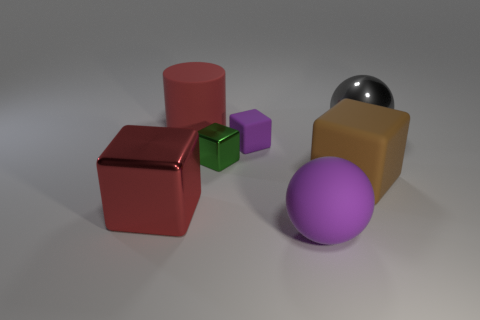Is the small matte object the same color as the big rubber sphere?
Make the answer very short. Yes. How many other objects are there of the same material as the large red cylinder?
Provide a short and direct response. 3. Are there an equal number of purple objects in front of the big red shiny object and small purple rubber blocks?
Make the answer very short. Yes. Is the size of the shiny thing that is to the right of the green metal block the same as the big red block?
Make the answer very short. Yes. What number of purple matte blocks are in front of the brown matte object?
Your answer should be very brief. 0. There is a large thing that is both left of the tiny purple object and to the right of the big red cube; what is its material?
Your response must be concise. Rubber. How many big things are green metal objects or red things?
Provide a succinct answer. 2. How big is the green shiny object?
Provide a short and direct response. Small. What is the shape of the gray object?
Your answer should be very brief. Sphere. Is there anything else that is the same shape as the gray object?
Keep it short and to the point. Yes. 